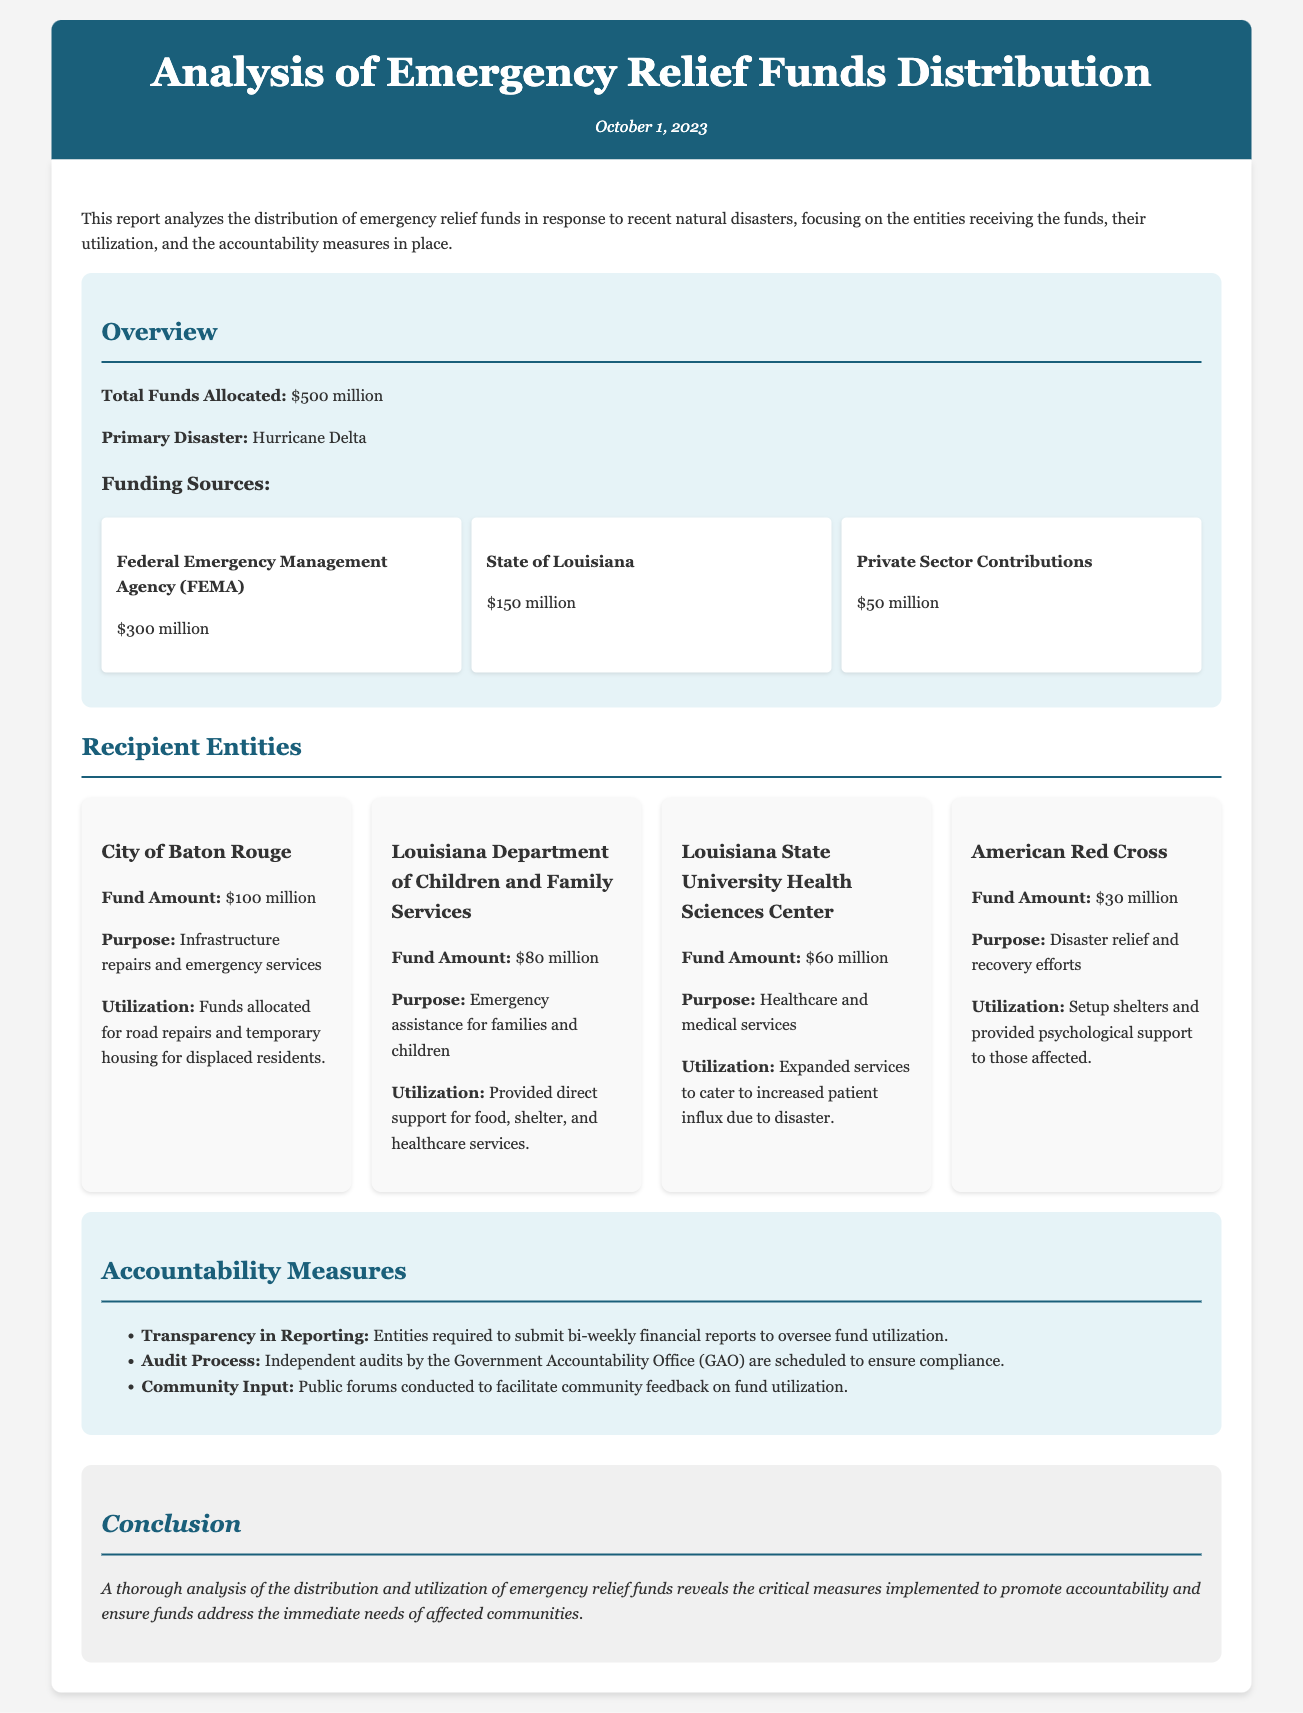what is the total funds allocated? The total funds allocated is explicitly stated in the document as $500 million.
Answer: $500 million who is the primary disaster associated with the funding? The primary disaster mentioned in the report is Hurricane Delta.
Answer: Hurricane Delta how much funding did the City of Baton Rouge receive? The report specifies that the City of Baton Rouge received $100 million.
Answer: $100 million what purpose did the Louisiana Department of Children and Family Services have for the funds? The purpose for the funds by the Louisiana Department of Children and Family Services is for emergency assistance for families and children.
Answer: Emergency assistance for families and children how often are the financial reports required to be submitted? The document states that entities are required to submit bi-weekly financial reports.
Answer: bi-weekly which entity received the least amount of funding? According to the document, the American Red Cross received the least amount of funding at $30 million.
Answer: American Red Cross what is one measure for ensuring accountability in fund utilization? The document mentions several accountability measures, one of which is the independent audits by the Government Accountability Office (GAO).
Answer: independent audits by the Government Accountability Office (GAO) how much funding was provided by Private Sector Contributions? The report indicates that Private Sector Contributions amounted to $50 million.
Answer: $50 million what is the purpose of the funds for Louisiana State University Health Sciences Center? The funds for Louisiana State University Health Sciences Center are for healthcare and medical services.
Answer: healthcare and medical services 